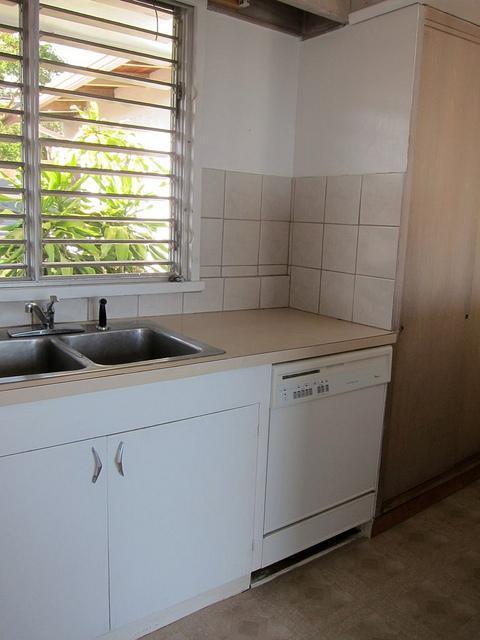How many sinks can be seen?
Give a very brief answer. 2. How many boys are in this photo?
Give a very brief answer. 0. 